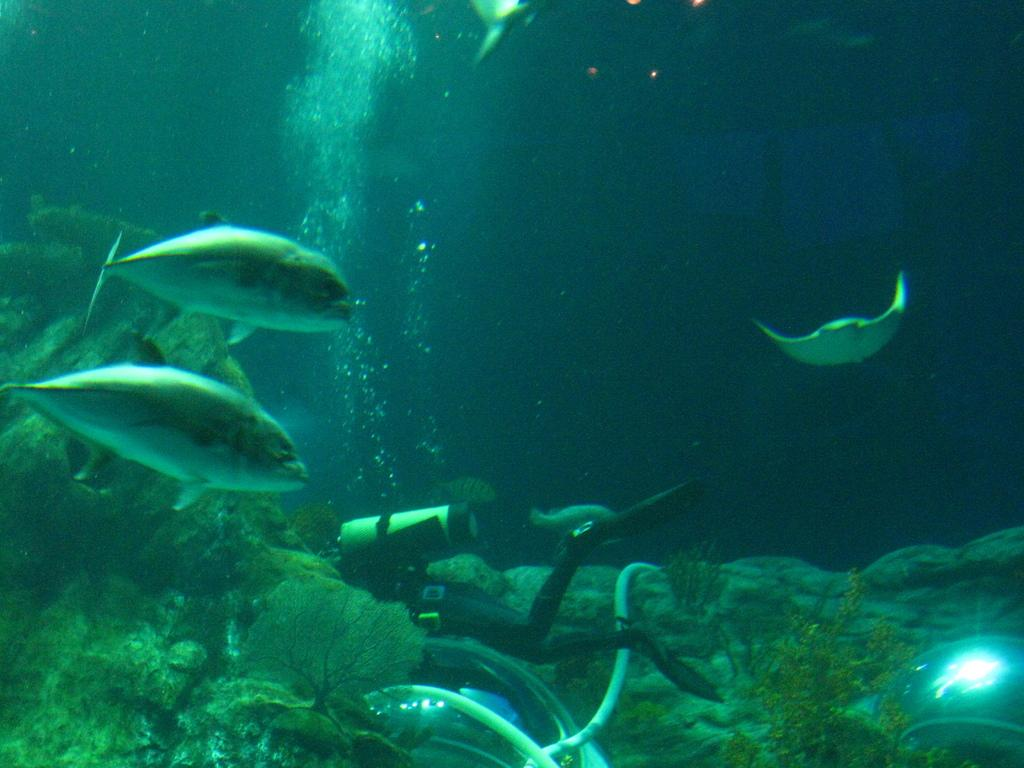What is the primary element in the image? There is water in the image. What can be found in the water? There are fishes in the water. Is there any human presence in the image? Yes, there is a person in the image. What is the object near the person? There is a gas cylinder in the image. How would you describe the lighting in the image? The image appears to be slightly dark. What type of pen is the person holding in the image? There is no pen present in the image. 